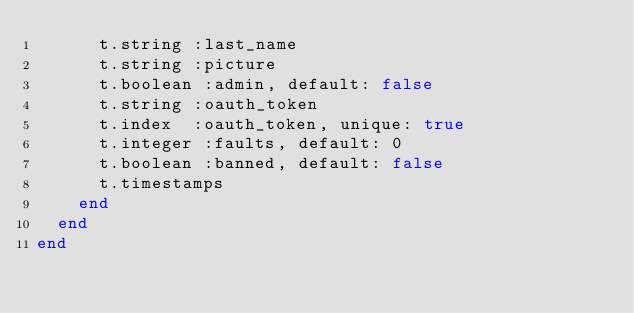Convert code to text. <code><loc_0><loc_0><loc_500><loc_500><_Ruby_>      t.string :last_name
      t.string :picture
      t.boolean :admin, default: false
      t.string :oauth_token
      t.index  :oauth_token, unique: true
      t.integer :faults, default: 0
      t.boolean :banned, default: false
      t.timestamps
    end
  end
end
</code> 